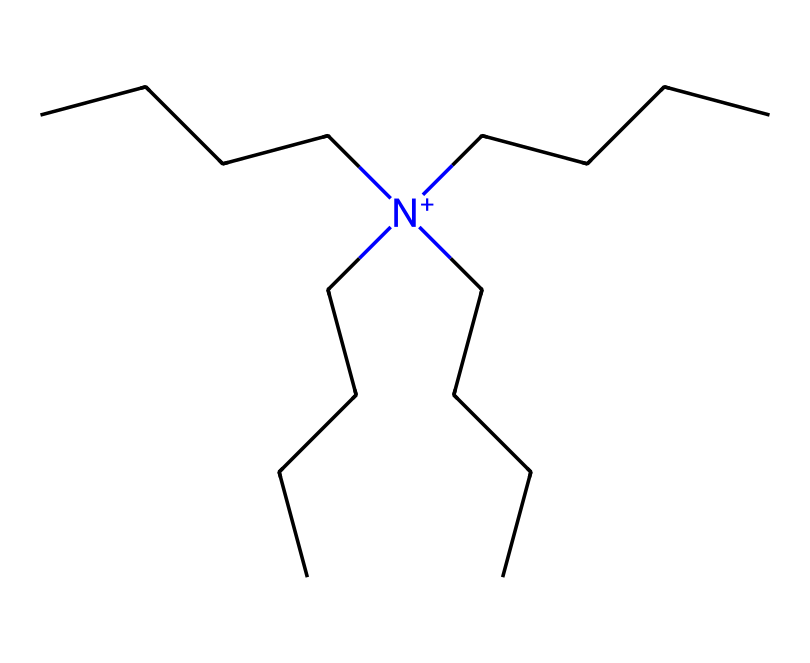What type of compound is represented by this structure? The presence of a nitrogen atom with four alkyl chains indicates that it is a quaternary ammonium compound. Specifically, these compounds are categorized as cationic surfactants, often used in fabric softeners and disinfectants.
Answer: quaternary ammonium compound How many carbon atoms are there in the longest alkyl chain? By analyzing the structure, it can be seen that there are four carbon chains branching from the nitrogen atom, with each chain consisting of four carbon atoms. Thus, the longest alkyl chain has four carbon atoms.
Answer: four What is the charge of the nitrogen atom in this compound? The nitrogen atom in quaternary ammonium compounds is positively charged due to its bonding with four carbon groups, making it a quaternary ammonium. Therefore, the charge is +1.
Answer: +1 What is the functional group present in this chemical? The primary functional group in this structure is the quaternary ammonium group, characterized by the nitrogen atom bonded to four hydrocarbons. This specific arrangement defines its chemical behavior.
Answer: quaternary ammonium group Why are these compounds commonly used in fabric softeners? The long hydrophobic alkyl chains in this structure provide excellent lubrication and softness, while the positive charge of the nitrogen interacts effectively with negatively charged surfaces, such as fabric fibers. This combination of hydrophobic and hydrophilic properties makes them ideal for fabric softening.
Answer: lubrication and softness What role does the quaternary ammonium compound play in disinfectants? Quaternary ammonium compounds are effective as disinfectants due to their ability to disrupt microbial cell membranes through their cationic nature, leading to cell lysis and microbial death. This property is derived from the compound's positive charge.
Answer: disrupt microbial cell membranes 